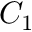<formula> <loc_0><loc_0><loc_500><loc_500>C _ { 1 }</formula> 